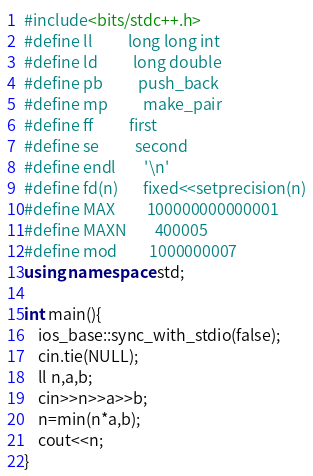Convert code to text. <code><loc_0><loc_0><loc_500><loc_500><_C++_>#include<bits/stdc++.h>
#define ll          long long int
#define ld          long double
#define pb          push_back
#define mp          make_pair
#define ff          first
#define se          second
#define endl        '\n'
#define fd(n)       fixed<<setprecision(n)
#define MAX         100000000000001
#define MAXN        400005
#define mod         1000000007
using namespace std;

int main(){
    ios_base::sync_with_stdio(false);
    cin.tie(NULL);
    ll n,a,b;
    cin>>n>>a>>b;
    n=min(n*a,b);
    cout<<n;
}</code> 